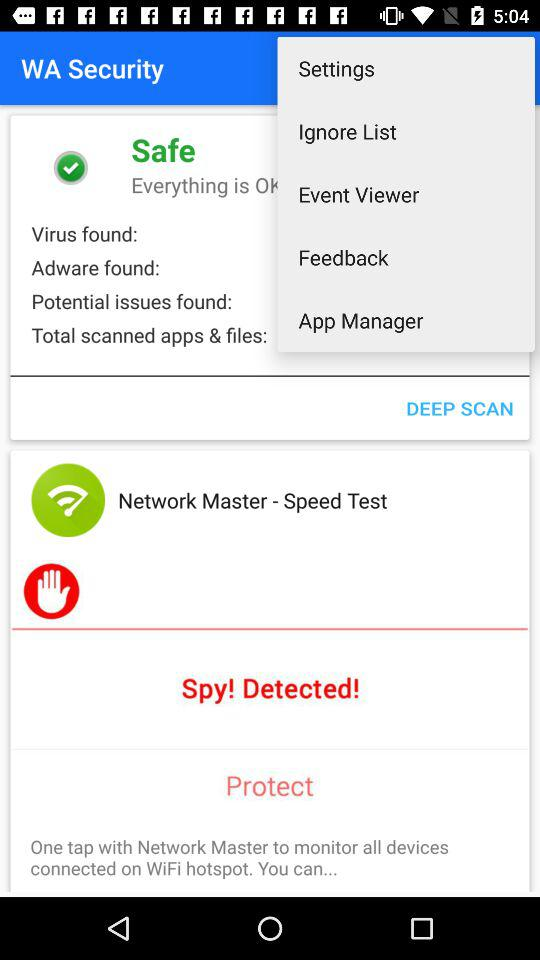When was the last deep scan?
When the provided information is insufficient, respond with <no answer>. <no answer> 